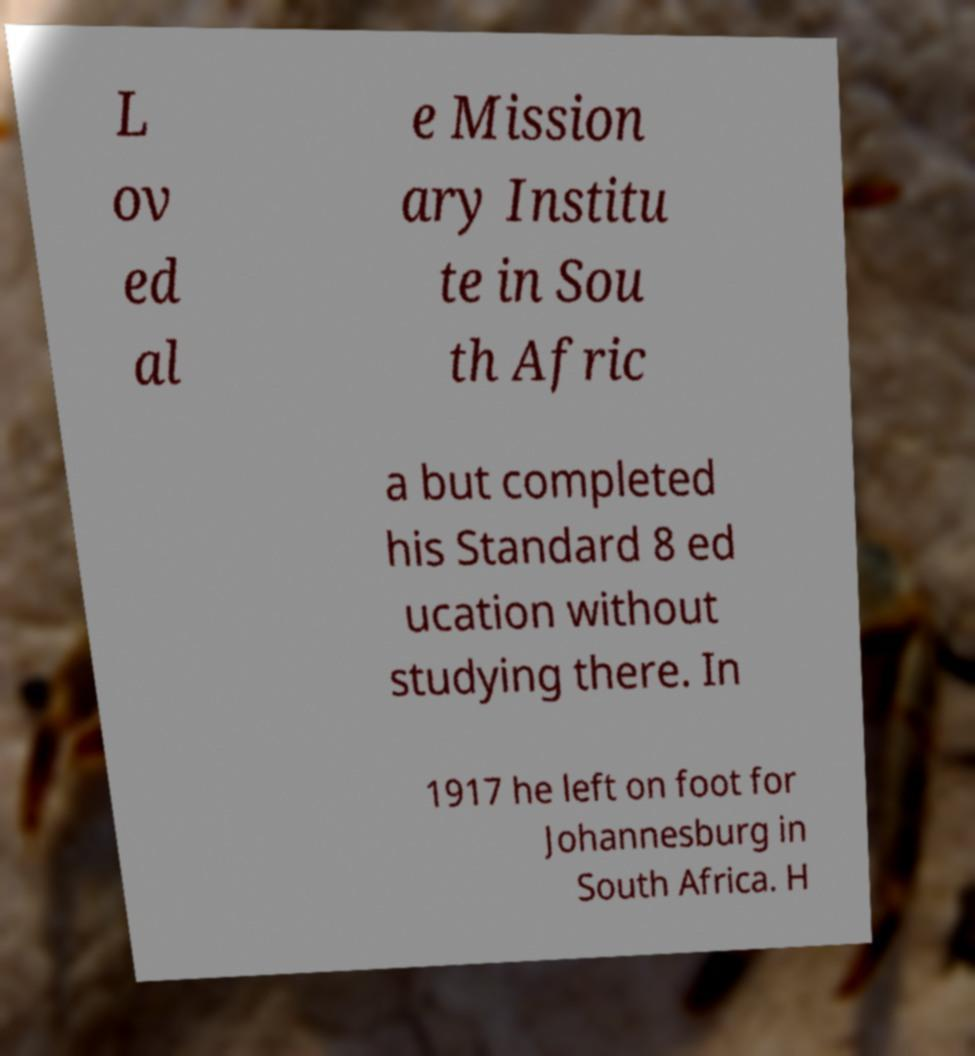What messages or text are displayed in this image? I need them in a readable, typed format. L ov ed al e Mission ary Institu te in Sou th Afric a but completed his Standard 8 ed ucation without studying there. In 1917 he left on foot for Johannesburg in South Africa. H 